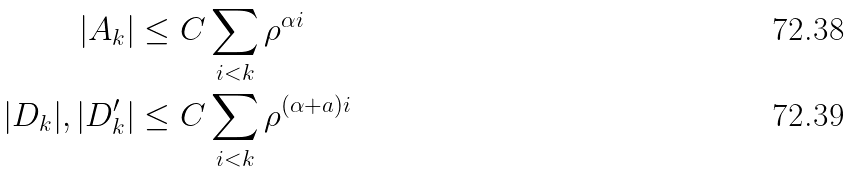<formula> <loc_0><loc_0><loc_500><loc_500>| A _ { k } | & \leq C \sum _ { i < k } \rho ^ { \alpha i } \\ | D _ { k } | , | D _ { k } ^ { \prime } | & \leq C \sum _ { i < k } \rho ^ { ( \alpha + a ) i }</formula> 